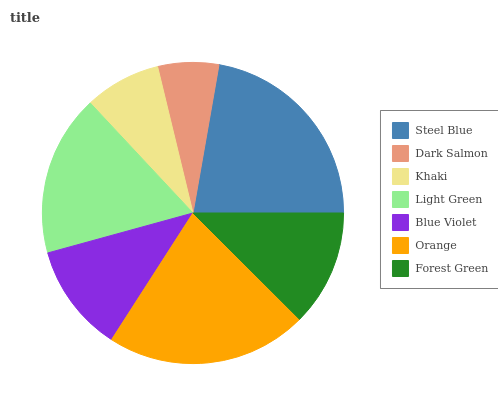Is Dark Salmon the minimum?
Answer yes or no. Yes. Is Steel Blue the maximum?
Answer yes or no. Yes. Is Khaki the minimum?
Answer yes or no. No. Is Khaki the maximum?
Answer yes or no. No. Is Khaki greater than Dark Salmon?
Answer yes or no. Yes. Is Dark Salmon less than Khaki?
Answer yes or no. Yes. Is Dark Salmon greater than Khaki?
Answer yes or no. No. Is Khaki less than Dark Salmon?
Answer yes or no. No. Is Forest Green the high median?
Answer yes or no. Yes. Is Forest Green the low median?
Answer yes or no. Yes. Is Orange the high median?
Answer yes or no. No. Is Blue Violet the low median?
Answer yes or no. No. 